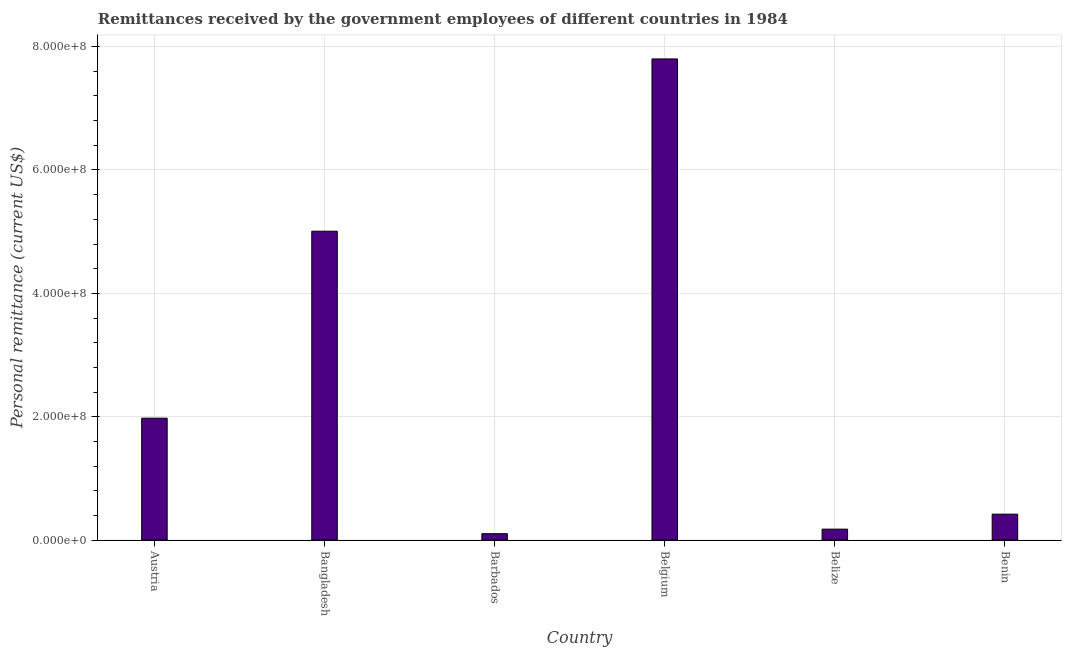Does the graph contain any zero values?
Your response must be concise. No. What is the title of the graph?
Provide a succinct answer. Remittances received by the government employees of different countries in 1984. What is the label or title of the Y-axis?
Offer a very short reply. Personal remittance (current US$). What is the personal remittances in Barbados?
Ensure brevity in your answer.  1.04e+07. Across all countries, what is the maximum personal remittances?
Offer a very short reply. 7.80e+08. Across all countries, what is the minimum personal remittances?
Your response must be concise. 1.04e+07. In which country was the personal remittances minimum?
Offer a terse response. Barbados. What is the sum of the personal remittances?
Offer a very short reply. 1.55e+09. What is the difference between the personal remittances in Austria and Belize?
Your answer should be very brief. 1.80e+08. What is the average personal remittances per country?
Offer a very short reply. 2.58e+08. What is the median personal remittances?
Your answer should be compact. 1.20e+08. What is the ratio of the personal remittances in Barbados to that in Benin?
Make the answer very short. 0.25. Is the personal remittances in Bangladesh less than that in Belize?
Your response must be concise. No. What is the difference between the highest and the second highest personal remittances?
Your answer should be very brief. 2.79e+08. Is the sum of the personal remittances in Belgium and Benin greater than the maximum personal remittances across all countries?
Ensure brevity in your answer.  Yes. What is the difference between the highest and the lowest personal remittances?
Keep it short and to the point. 7.70e+08. In how many countries, is the personal remittances greater than the average personal remittances taken over all countries?
Your answer should be compact. 2. Are all the bars in the graph horizontal?
Offer a very short reply. No. Are the values on the major ticks of Y-axis written in scientific E-notation?
Make the answer very short. Yes. What is the Personal remittance (current US$) of Austria?
Ensure brevity in your answer.  1.98e+08. What is the Personal remittance (current US$) in Bangladesh?
Offer a terse response. 5.01e+08. What is the Personal remittance (current US$) of Barbados?
Your answer should be compact. 1.04e+07. What is the Personal remittance (current US$) in Belgium?
Offer a terse response. 7.80e+08. What is the Personal remittance (current US$) in Belize?
Give a very brief answer. 1.78e+07. What is the Personal remittance (current US$) in Benin?
Give a very brief answer. 4.21e+07. What is the difference between the Personal remittance (current US$) in Austria and Bangladesh?
Your response must be concise. -3.03e+08. What is the difference between the Personal remittance (current US$) in Austria and Barbados?
Offer a terse response. 1.87e+08. What is the difference between the Personal remittance (current US$) in Austria and Belgium?
Keep it short and to the point. -5.82e+08. What is the difference between the Personal remittance (current US$) in Austria and Belize?
Your answer should be very brief. 1.80e+08. What is the difference between the Personal remittance (current US$) in Austria and Benin?
Provide a short and direct response. 1.56e+08. What is the difference between the Personal remittance (current US$) in Bangladesh and Barbados?
Provide a succinct answer. 4.90e+08. What is the difference between the Personal remittance (current US$) in Bangladesh and Belgium?
Ensure brevity in your answer.  -2.79e+08. What is the difference between the Personal remittance (current US$) in Bangladesh and Belize?
Your response must be concise. 4.83e+08. What is the difference between the Personal remittance (current US$) in Bangladesh and Benin?
Ensure brevity in your answer.  4.59e+08. What is the difference between the Personal remittance (current US$) in Barbados and Belgium?
Provide a succinct answer. -7.70e+08. What is the difference between the Personal remittance (current US$) in Barbados and Belize?
Your answer should be compact. -7.35e+06. What is the difference between the Personal remittance (current US$) in Barbados and Benin?
Provide a succinct answer. -3.17e+07. What is the difference between the Personal remittance (current US$) in Belgium and Belize?
Ensure brevity in your answer.  7.62e+08. What is the difference between the Personal remittance (current US$) in Belgium and Benin?
Make the answer very short. 7.38e+08. What is the difference between the Personal remittance (current US$) in Belize and Benin?
Offer a terse response. -2.43e+07. What is the ratio of the Personal remittance (current US$) in Austria to that in Bangladesh?
Your answer should be very brief. 0.4. What is the ratio of the Personal remittance (current US$) in Austria to that in Barbados?
Provide a short and direct response. 19.01. What is the ratio of the Personal remittance (current US$) in Austria to that in Belgium?
Provide a succinct answer. 0.25. What is the ratio of the Personal remittance (current US$) in Austria to that in Belize?
Your response must be concise. 11.14. What is the ratio of the Personal remittance (current US$) in Austria to that in Benin?
Make the answer very short. 4.7. What is the ratio of the Personal remittance (current US$) in Bangladesh to that in Barbados?
Your answer should be very brief. 48.15. What is the ratio of the Personal remittance (current US$) in Bangladesh to that in Belgium?
Keep it short and to the point. 0.64. What is the ratio of the Personal remittance (current US$) in Bangladesh to that in Belize?
Your response must be concise. 28.21. What is the ratio of the Personal remittance (current US$) in Bangladesh to that in Benin?
Provide a succinct answer. 11.9. What is the ratio of the Personal remittance (current US$) in Barbados to that in Belgium?
Ensure brevity in your answer.  0.01. What is the ratio of the Personal remittance (current US$) in Barbados to that in Belize?
Give a very brief answer. 0.59. What is the ratio of the Personal remittance (current US$) in Barbados to that in Benin?
Give a very brief answer. 0.25. What is the ratio of the Personal remittance (current US$) in Belgium to that in Belize?
Offer a terse response. 43.95. What is the ratio of the Personal remittance (current US$) in Belgium to that in Benin?
Offer a terse response. 18.54. What is the ratio of the Personal remittance (current US$) in Belize to that in Benin?
Give a very brief answer. 0.42. 